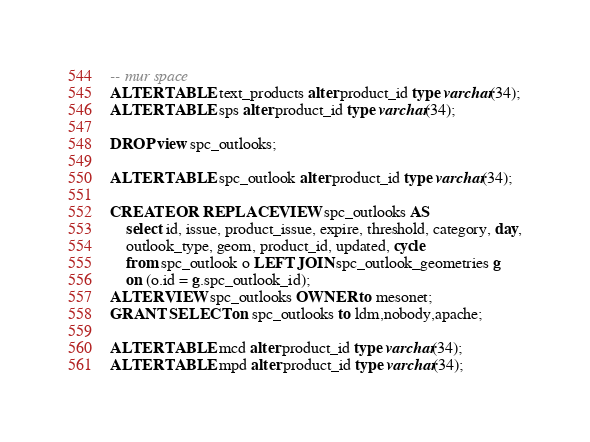<code> <loc_0><loc_0><loc_500><loc_500><_SQL_>-- mur space
ALTER TABLE text_products alter product_id type varchar(34);
ALTER TABLE sps alter product_id type varchar(34);

DROP view spc_outlooks;

ALTER TABLE spc_outlook alter product_id type varchar(34);

CREATE OR REPLACE VIEW spc_outlooks AS
    select id, issue, product_issue, expire, threshold, category, day,
    outlook_type, geom, product_id, updated, cycle
    from spc_outlook o LEFT JOIN spc_outlook_geometries g
    on (o.id = g.spc_outlook_id);
ALTER VIEW spc_outlooks OWNER to mesonet;
GRANT SELECT on spc_outlooks to ldm,nobody,apache;

ALTER TABLE mcd alter product_id type varchar(34);
ALTER TABLE mpd alter product_id type varchar(34);
</code> 